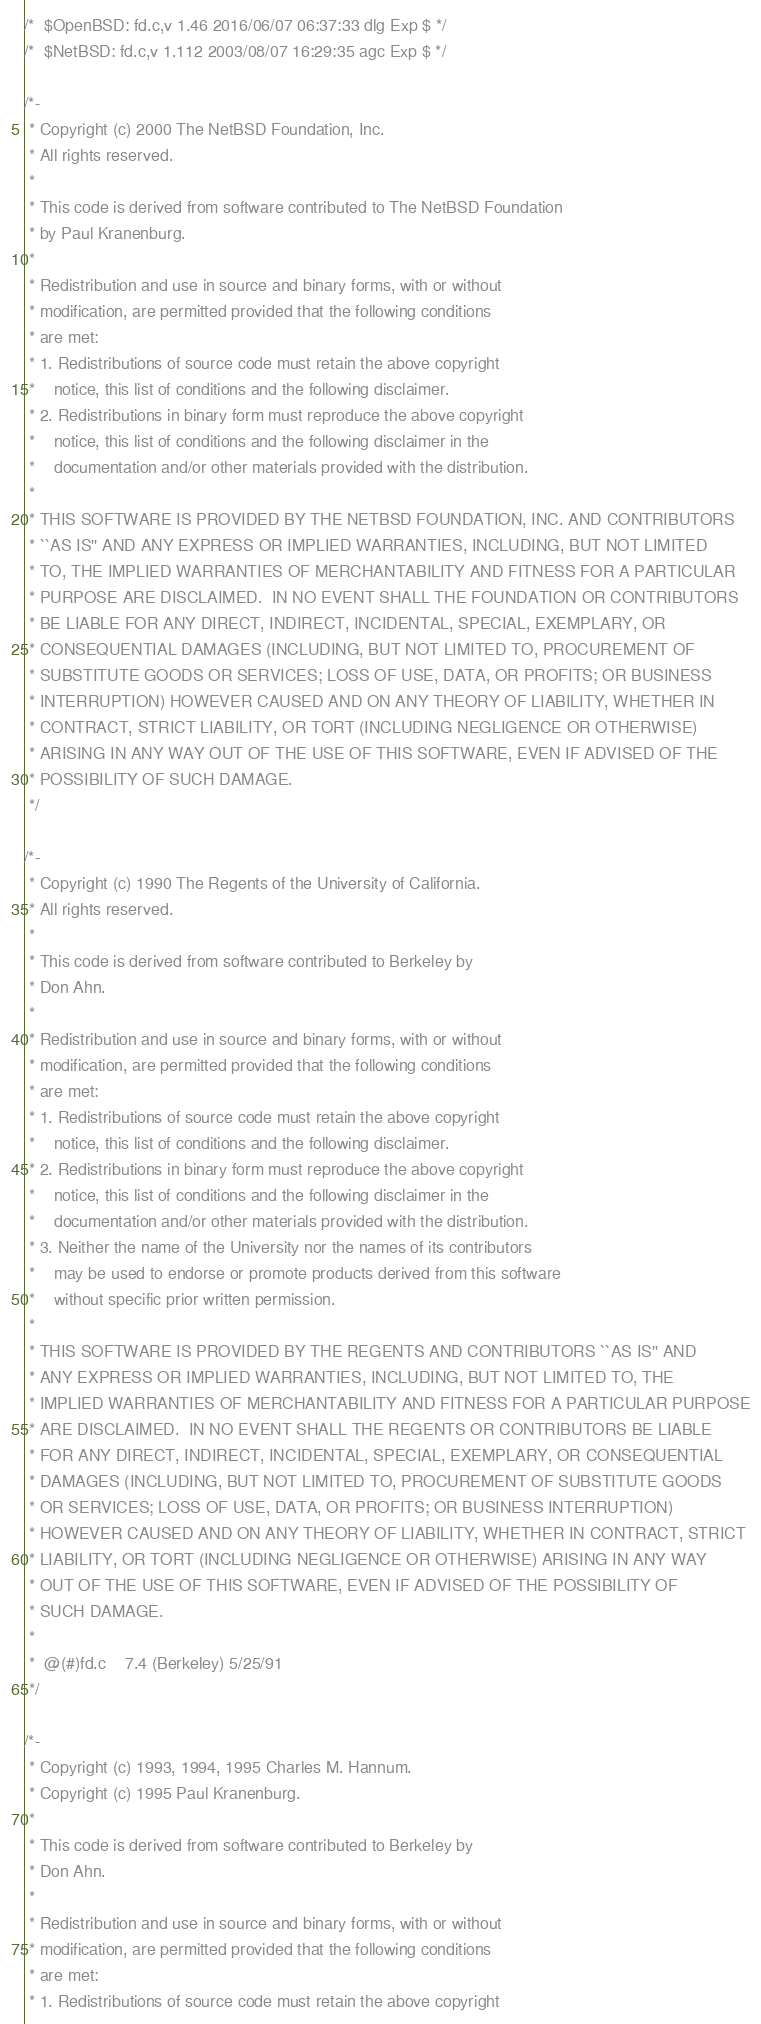Convert code to text. <code><loc_0><loc_0><loc_500><loc_500><_C_>/*	$OpenBSD: fd.c,v 1.46 2016/06/07 06:37:33 dlg Exp $	*/
/*	$NetBSD: fd.c,v 1.112 2003/08/07 16:29:35 agc Exp $	*/

/*-
 * Copyright (c) 2000 The NetBSD Foundation, Inc.
 * All rights reserved.
 *
 * This code is derived from software contributed to The NetBSD Foundation
 * by Paul Kranenburg.
 *
 * Redistribution and use in source and binary forms, with or without
 * modification, are permitted provided that the following conditions
 * are met:
 * 1. Redistributions of source code must retain the above copyright
 *    notice, this list of conditions and the following disclaimer.
 * 2. Redistributions in binary form must reproduce the above copyright
 *    notice, this list of conditions and the following disclaimer in the
 *    documentation and/or other materials provided with the distribution.
 *
 * THIS SOFTWARE IS PROVIDED BY THE NETBSD FOUNDATION, INC. AND CONTRIBUTORS
 * ``AS IS'' AND ANY EXPRESS OR IMPLIED WARRANTIES, INCLUDING, BUT NOT LIMITED
 * TO, THE IMPLIED WARRANTIES OF MERCHANTABILITY AND FITNESS FOR A PARTICULAR
 * PURPOSE ARE DISCLAIMED.  IN NO EVENT SHALL THE FOUNDATION OR CONTRIBUTORS
 * BE LIABLE FOR ANY DIRECT, INDIRECT, INCIDENTAL, SPECIAL, EXEMPLARY, OR
 * CONSEQUENTIAL DAMAGES (INCLUDING, BUT NOT LIMITED TO, PROCUREMENT OF
 * SUBSTITUTE GOODS OR SERVICES; LOSS OF USE, DATA, OR PROFITS; OR BUSINESS
 * INTERRUPTION) HOWEVER CAUSED AND ON ANY THEORY OF LIABILITY, WHETHER IN
 * CONTRACT, STRICT LIABILITY, OR TORT (INCLUDING NEGLIGENCE OR OTHERWISE)
 * ARISING IN ANY WAY OUT OF THE USE OF THIS SOFTWARE, EVEN IF ADVISED OF THE
 * POSSIBILITY OF SUCH DAMAGE.
 */

/*-
 * Copyright (c) 1990 The Regents of the University of California.
 * All rights reserved.
 *
 * This code is derived from software contributed to Berkeley by
 * Don Ahn.
 *
 * Redistribution and use in source and binary forms, with or without
 * modification, are permitted provided that the following conditions
 * are met:
 * 1. Redistributions of source code must retain the above copyright
 *    notice, this list of conditions and the following disclaimer.
 * 2. Redistributions in binary form must reproduce the above copyright
 *    notice, this list of conditions and the following disclaimer in the
 *    documentation and/or other materials provided with the distribution.
 * 3. Neither the name of the University nor the names of its contributors
 *    may be used to endorse or promote products derived from this software
 *    without specific prior written permission.
 *
 * THIS SOFTWARE IS PROVIDED BY THE REGENTS AND CONTRIBUTORS ``AS IS'' AND
 * ANY EXPRESS OR IMPLIED WARRANTIES, INCLUDING, BUT NOT LIMITED TO, THE
 * IMPLIED WARRANTIES OF MERCHANTABILITY AND FITNESS FOR A PARTICULAR PURPOSE
 * ARE DISCLAIMED.  IN NO EVENT SHALL THE REGENTS OR CONTRIBUTORS BE LIABLE
 * FOR ANY DIRECT, INDIRECT, INCIDENTAL, SPECIAL, EXEMPLARY, OR CONSEQUENTIAL
 * DAMAGES (INCLUDING, BUT NOT LIMITED TO, PROCUREMENT OF SUBSTITUTE GOODS
 * OR SERVICES; LOSS OF USE, DATA, OR PROFITS; OR BUSINESS INTERRUPTION)
 * HOWEVER CAUSED AND ON ANY THEORY OF LIABILITY, WHETHER IN CONTRACT, STRICT
 * LIABILITY, OR TORT (INCLUDING NEGLIGENCE OR OTHERWISE) ARISING IN ANY WAY
 * OUT OF THE USE OF THIS SOFTWARE, EVEN IF ADVISED OF THE POSSIBILITY OF
 * SUCH DAMAGE.
 *
 *	@(#)fd.c	7.4 (Berkeley) 5/25/91
 */

/*-
 * Copyright (c) 1993, 1994, 1995 Charles M. Hannum.
 * Copyright (c) 1995 Paul Kranenburg.
 *
 * This code is derived from software contributed to Berkeley by
 * Don Ahn.
 *
 * Redistribution and use in source and binary forms, with or without
 * modification, are permitted provided that the following conditions
 * are met:
 * 1. Redistributions of source code must retain the above copyright</code> 